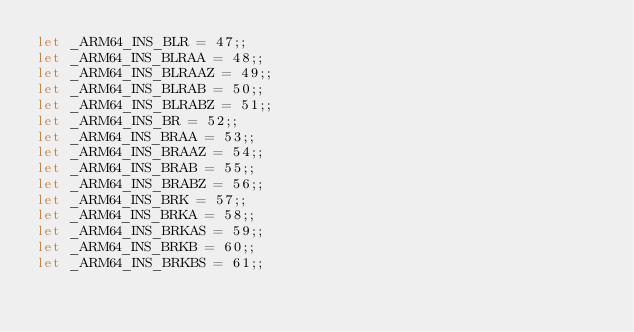Convert code to text. <code><loc_0><loc_0><loc_500><loc_500><_OCaml_>let _ARM64_INS_BLR = 47;;
let _ARM64_INS_BLRAA = 48;;
let _ARM64_INS_BLRAAZ = 49;;
let _ARM64_INS_BLRAB = 50;;
let _ARM64_INS_BLRABZ = 51;;
let _ARM64_INS_BR = 52;;
let _ARM64_INS_BRAA = 53;;
let _ARM64_INS_BRAAZ = 54;;
let _ARM64_INS_BRAB = 55;;
let _ARM64_INS_BRABZ = 56;;
let _ARM64_INS_BRK = 57;;
let _ARM64_INS_BRKA = 58;;
let _ARM64_INS_BRKAS = 59;;
let _ARM64_INS_BRKB = 60;;
let _ARM64_INS_BRKBS = 61;;</code> 